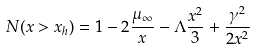<formula> <loc_0><loc_0><loc_500><loc_500>N ( x > x _ { h } ) = 1 - 2 \frac { \mu _ { \infty } } { x } - \Lambda \frac { x ^ { 2 } } { 3 } + \frac { \gamma ^ { 2 } } { 2 x ^ { 2 } }</formula> 